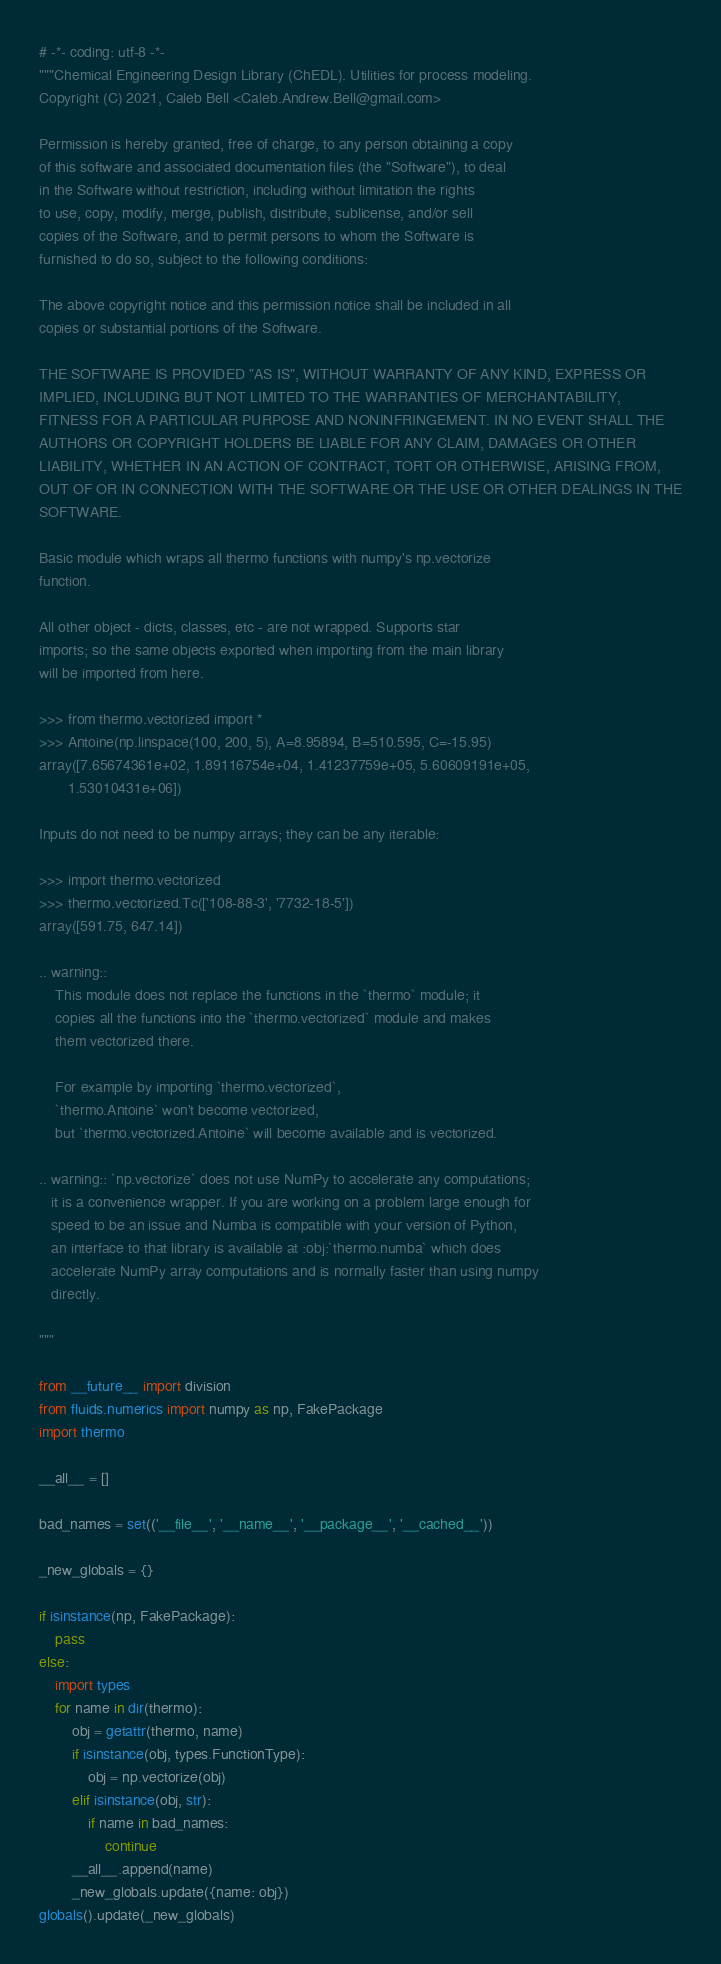<code> <loc_0><loc_0><loc_500><loc_500><_Python_># -*- coding: utf-8 -*-
"""Chemical Engineering Design Library (ChEDL). Utilities for process modeling.
Copyright (C) 2021, Caleb Bell <Caleb.Andrew.Bell@gmail.com>

Permission is hereby granted, free of charge, to any person obtaining a copy
of this software and associated documentation files (the "Software"), to deal
in the Software without restriction, including without limitation the rights
to use, copy, modify, merge, publish, distribute, sublicense, and/or sell
copies of the Software, and to permit persons to whom the Software is
furnished to do so, subject to the following conditions:

The above copyright notice and this permission notice shall be included in all
copies or substantial portions of the Software.

THE SOFTWARE IS PROVIDED "AS IS", WITHOUT WARRANTY OF ANY KIND, EXPRESS OR
IMPLIED, INCLUDING BUT NOT LIMITED TO THE WARRANTIES OF MERCHANTABILITY,
FITNESS FOR A PARTICULAR PURPOSE AND NONINFRINGEMENT. IN NO EVENT SHALL THE
AUTHORS OR COPYRIGHT HOLDERS BE LIABLE FOR ANY CLAIM, DAMAGES OR OTHER
LIABILITY, WHETHER IN AN ACTION OF CONTRACT, TORT OR OTHERWISE, ARISING FROM,
OUT OF OR IN CONNECTION WITH THE SOFTWARE OR THE USE OR OTHER DEALINGS IN THE
SOFTWARE.

Basic module which wraps all thermo functions with numpy's np.vectorize
function.

All other object - dicts, classes, etc - are not wrapped. Supports star
imports; so the same objects exported when importing from the main library
will be imported from here.

>>> from thermo.vectorized import *
>>> Antoine(np.linspace(100, 200, 5), A=8.95894, B=510.595, C=-15.95)
array([7.65674361e+02, 1.89116754e+04, 1.41237759e+05, 5.60609191e+05,
       1.53010431e+06])

Inputs do not need to be numpy arrays; they can be any iterable:

>>> import thermo.vectorized
>>> thermo.vectorized.Tc(['108-88-3', '7732-18-5'])
array([591.75, 647.14])

.. warning::
    This module does not replace the functions in the `thermo` module; it
    copies all the functions into the `thermo.vectorized` module and makes
    them vectorized there.

    For example by importing `thermo.vectorized`,
    `thermo.Antoine` won't become vectorized,
    but `thermo.vectorized.Antoine` will become available and is vectorized.

.. warning:: `np.vectorize` does not use NumPy to accelerate any computations;
   it is a convenience wrapper. If you are working on a problem large enough for
   speed to be an issue and Numba is compatible with your version of Python,
   an interface to that library is available at :obj:`thermo.numba` which does
   accelerate NumPy array computations and is normally faster than using numpy
   directly.

"""

from __future__ import division
from fluids.numerics import numpy as np, FakePackage
import thermo

__all__ = []

bad_names = set(('__file__', '__name__', '__package__', '__cached__'))

_new_globals = {}

if isinstance(np, FakePackage):
    pass
else:
    import types
    for name in dir(thermo):
        obj = getattr(thermo, name)
        if isinstance(obj, types.FunctionType):
            obj = np.vectorize(obj)
        elif isinstance(obj, str):
            if name in bad_names:
                continue
        __all__.append(name)
        _new_globals.update({name: obj})
globals().update(_new_globals)




</code> 